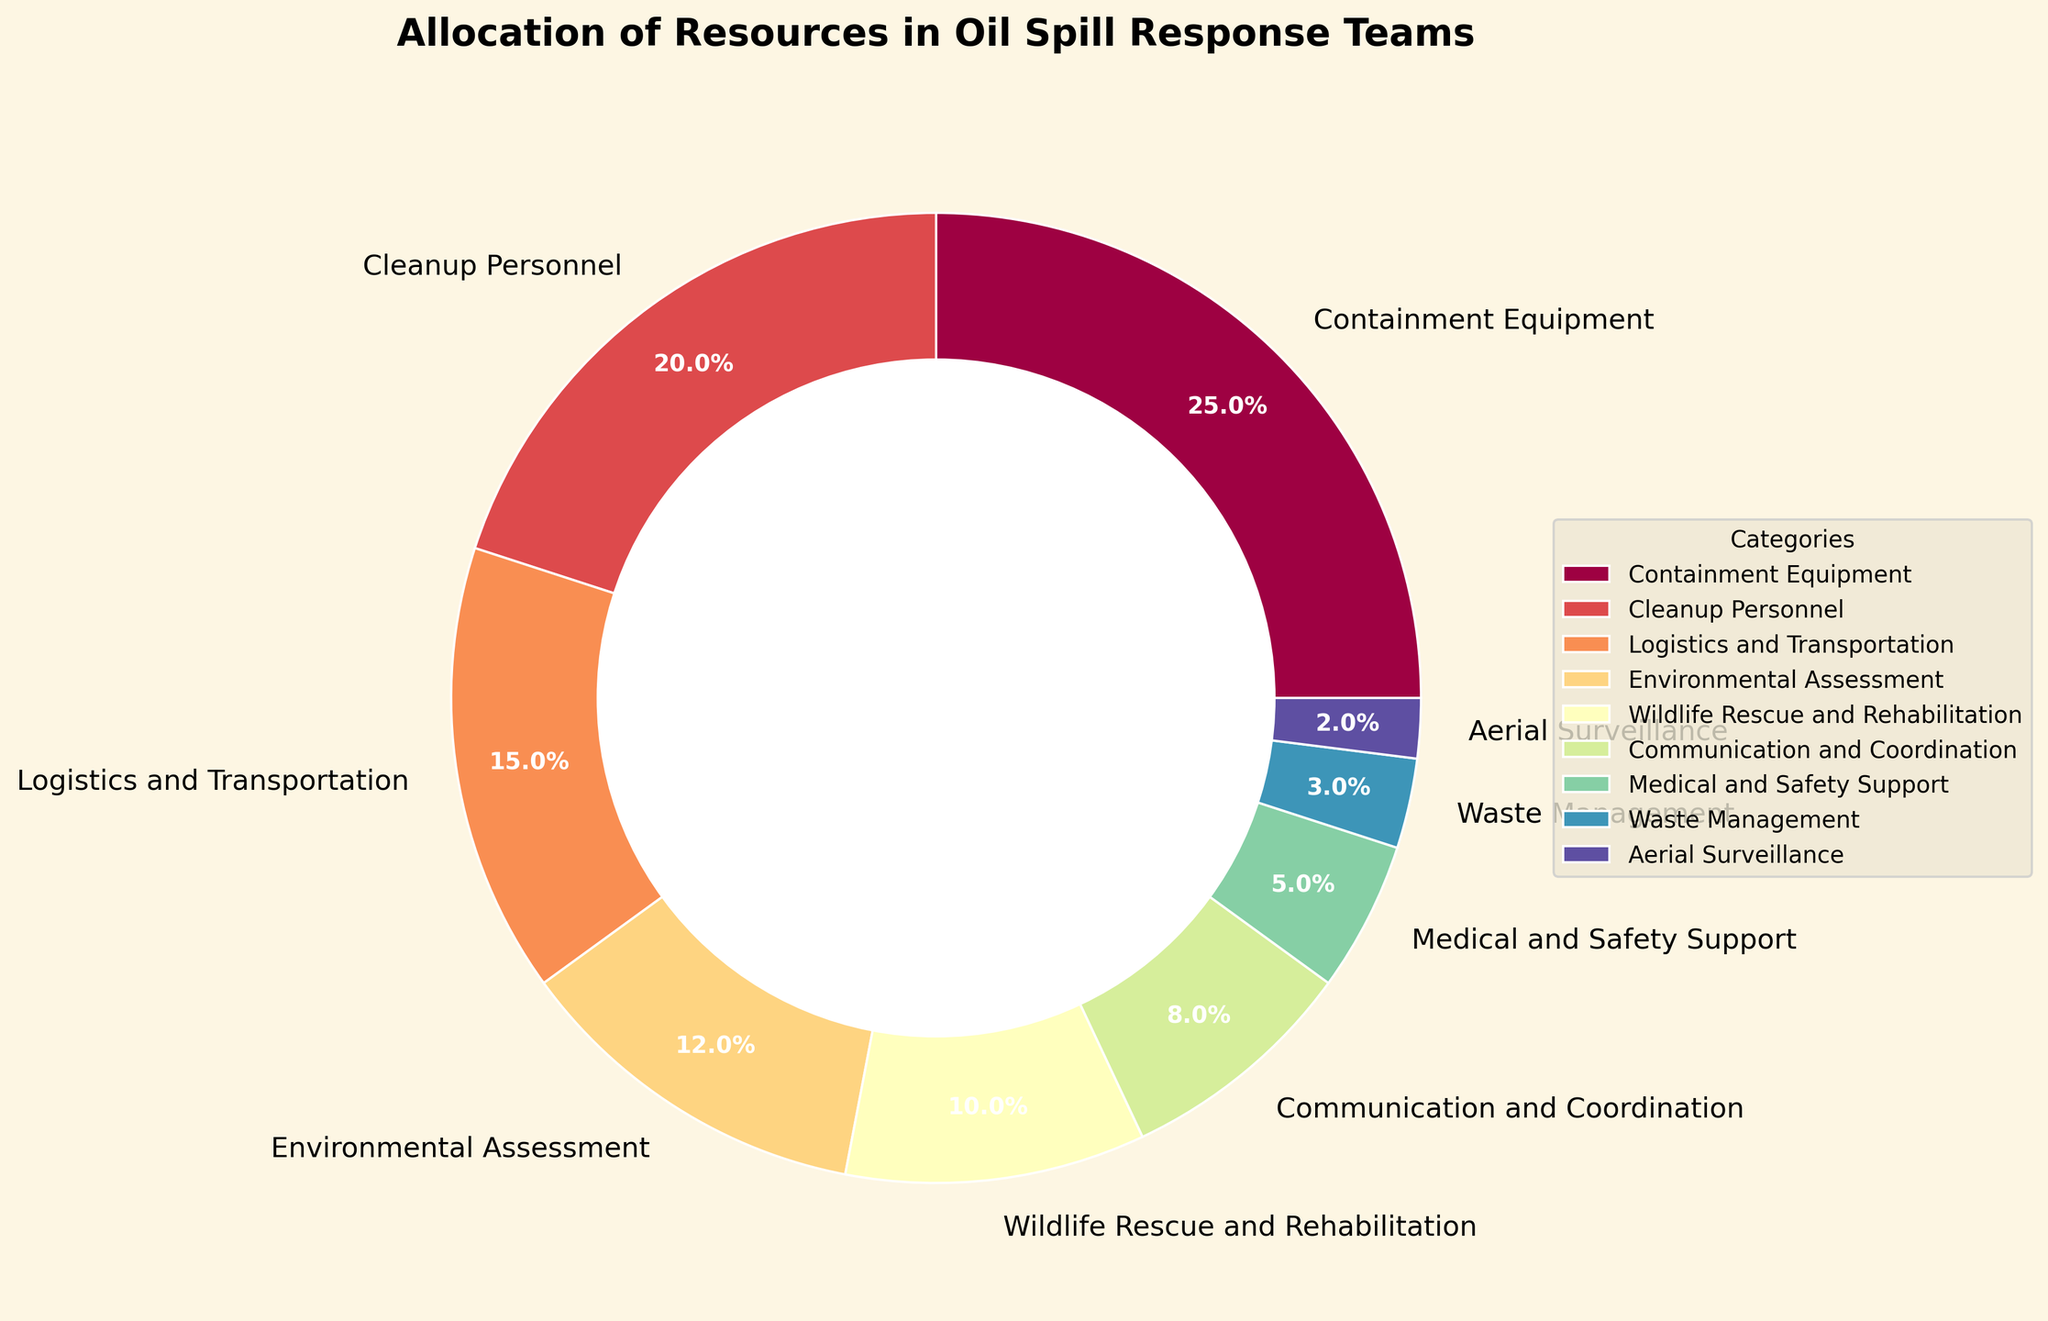What percentage of resources is allocated to Communication and Coordination? The pie chart shows each category's percentage of the total resources. For Communication and Coordination, the chart shows 8%.
Answer: 8% Which two categories have the highest allocation of resources? The categories with the highest and second-highest allocations are Containment Equipment (25%) and Cleanup Personnel (20%) respectively, as shown in the pie chart.
Answer: Containment Equipment and Cleanup Personnel What is the combined percentage of resources allocated to Medical and Safety Support and Waste Management? Add the percentage of Medical and Safety Support (5%) and Waste Management (3%) as indicated in the chart. 5% + 3% = 8%.
Answer: 8% Is more resources allocated to Wildlife Rescue and Rehabilitation or Logistics and Transportation? The pie chart shows 15% allocated to Logistics and Transportation and 10% to Wildlife Rescue and Rehabilitation. 15% is greater than 10%.
Answer: Logistics and Transportation Which category has the smallest allocation, and what is its percentage? The pie chart indicates that Aerial Surveillance has the smallest allocation at 2%.
Answer: Aerial Surveillance, 2% What is the total percentage of resources allocated to Cleanup Personnel, Environmental Assessment, and Wildlife Rescue and Rehabilitation? Add the percentages for Cleanup Personnel (20%), Environmental Assessment (12%), and Wildlife Rescue and Rehabilitation (10%) from the chart: 20% + 12% + 10% = 42%.
Answer: 42% How much more percentage of resources is allocated to Containment Equipment compared to Environmental Assessment? The chart shows 25% for Containment Equipment and 12% for Environmental Assessment. The difference is 25% - 12% = 13%.
Answer: 13% Are there more resources allocated to Logistics and Transportation or Communication and Coordination? The pie chart indicates 15% for Logistics and Transportation and 8% for Communication and Coordination. 15% is greater than 8%.
Answer: Logistics and Transportation What is the median value of the resource allocation percentages? List the percentages in ascending order: 2, 3, 5, 8, 10, 12, 15, 20, 25. The median is the middle value, which is 10.
Answer: 10% 